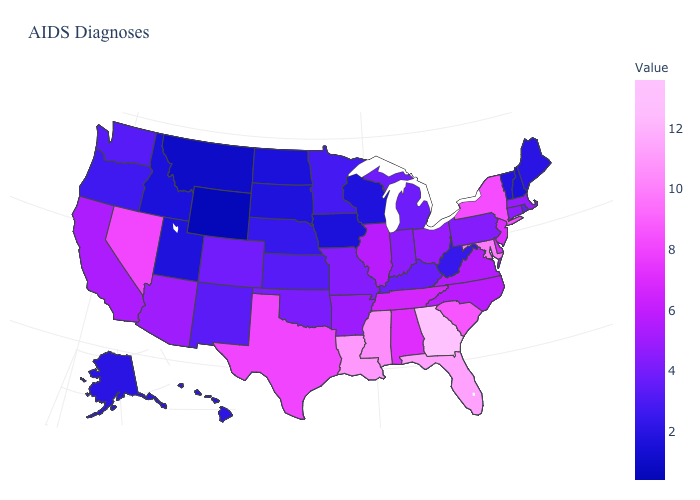Does Nevada have the highest value in the West?
Quick response, please. Yes. Does the map have missing data?
Short answer required. No. Which states have the lowest value in the MidWest?
Give a very brief answer. Iowa, North Dakota. Which states have the highest value in the USA?
Answer briefly. Georgia. 